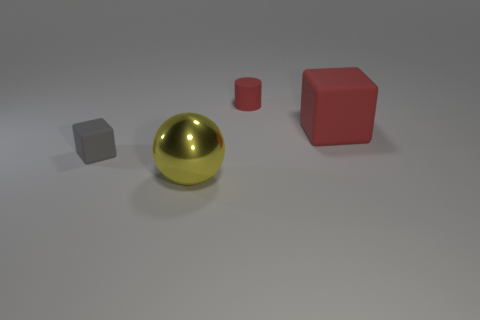Add 2 big yellow balls. How many objects exist? 6 Subtract all cylinders. How many objects are left? 3 Subtract 1 gray cubes. How many objects are left? 3 Subtract all metal spheres. Subtract all red things. How many objects are left? 1 Add 2 red objects. How many red objects are left? 4 Add 2 matte blocks. How many matte blocks exist? 4 